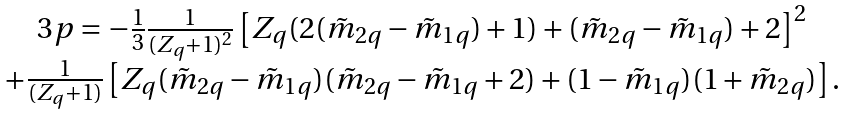<formula> <loc_0><loc_0><loc_500><loc_500>\begin{array} { c } 3 p = - \frac { 1 } { 3 } \frac { 1 } { ( Z _ { q } + 1 ) ^ { 2 } } \left [ Z _ { q } ( 2 ( \tilde { m } _ { 2 q } - \tilde { m } _ { 1 q } ) + 1 ) + ( \tilde { m } _ { 2 q } - \tilde { m } _ { 1 q } ) + 2 \right ] ^ { 2 } \\ + \frac { 1 } { ( Z _ { q } + 1 ) } \left [ Z _ { q } ( \tilde { m } _ { 2 q } - \tilde { m } _ { 1 q } ) ( \tilde { m } _ { 2 q } - \tilde { m } _ { 1 q } + 2 ) + ( 1 - \tilde { m } _ { 1 q } ) ( 1 + \tilde { m } _ { 2 q } ) \right ] . \end{array}</formula> 